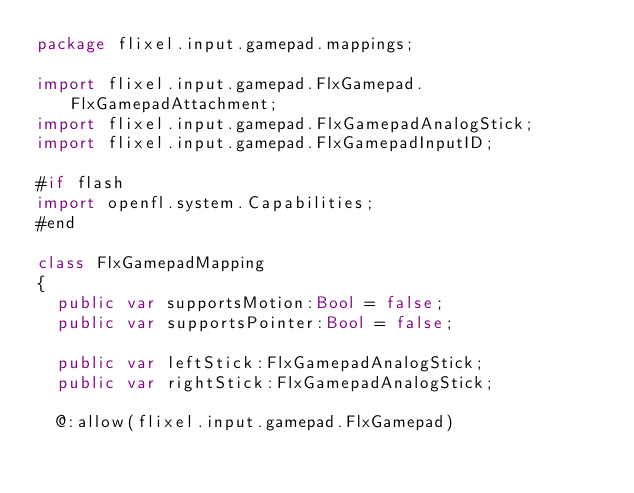Convert code to text. <code><loc_0><loc_0><loc_500><loc_500><_Haxe_>package flixel.input.gamepad.mappings;

import flixel.input.gamepad.FlxGamepad.FlxGamepadAttachment;
import flixel.input.gamepad.FlxGamepadAnalogStick;
import flixel.input.gamepad.FlxGamepadInputID;

#if flash
import openfl.system.Capabilities;
#end

class FlxGamepadMapping
{
	public var supportsMotion:Bool = false;
	public var supportsPointer:Bool = false;
	
	public var leftStick:FlxGamepadAnalogStick;
	public var rightStick:FlxGamepadAnalogStick;
	
	@:allow(flixel.input.gamepad.FlxGamepad)</code> 